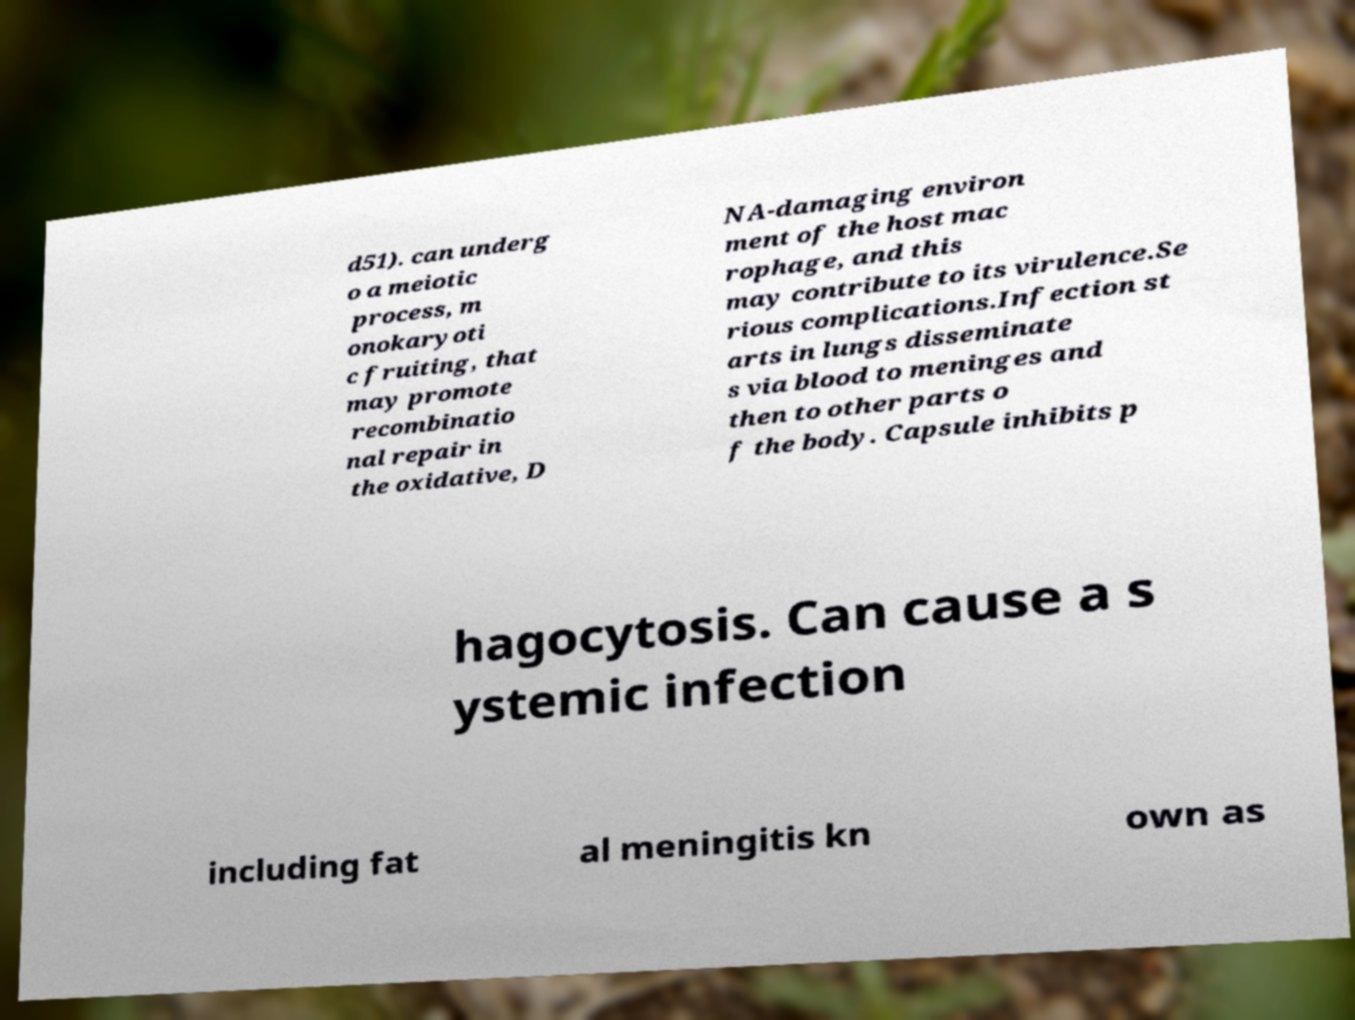What messages or text are displayed in this image? I need them in a readable, typed format. d51). can underg o a meiotic process, m onokaryoti c fruiting, that may promote recombinatio nal repair in the oxidative, D NA-damaging environ ment of the host mac rophage, and this may contribute to its virulence.Se rious complications.Infection st arts in lungs disseminate s via blood to meninges and then to other parts o f the body. Capsule inhibits p hagocytosis. Can cause a s ystemic infection including fat al meningitis kn own as 